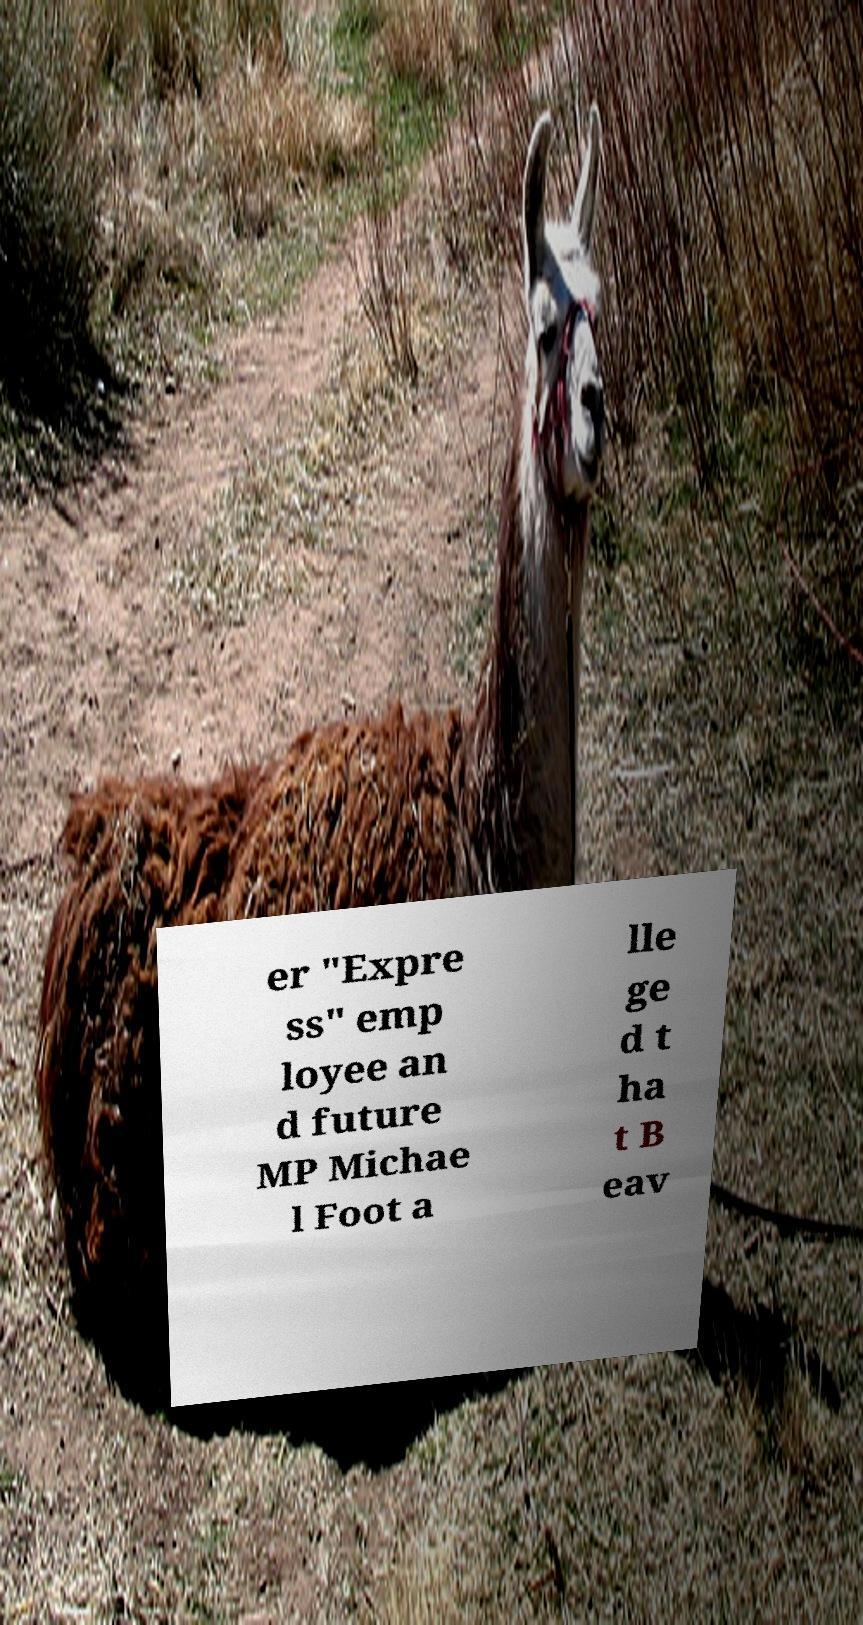I need the written content from this picture converted into text. Can you do that? er "Expre ss" emp loyee an d future MP Michae l Foot a lle ge d t ha t B eav 